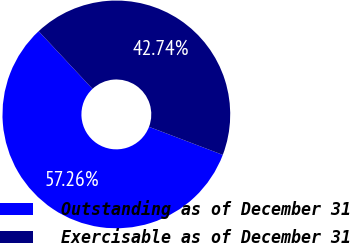Convert chart to OTSL. <chart><loc_0><loc_0><loc_500><loc_500><pie_chart><fcel>Outstanding as of December 31<fcel>Exercisable as of December 31<nl><fcel>57.26%<fcel>42.74%<nl></chart> 